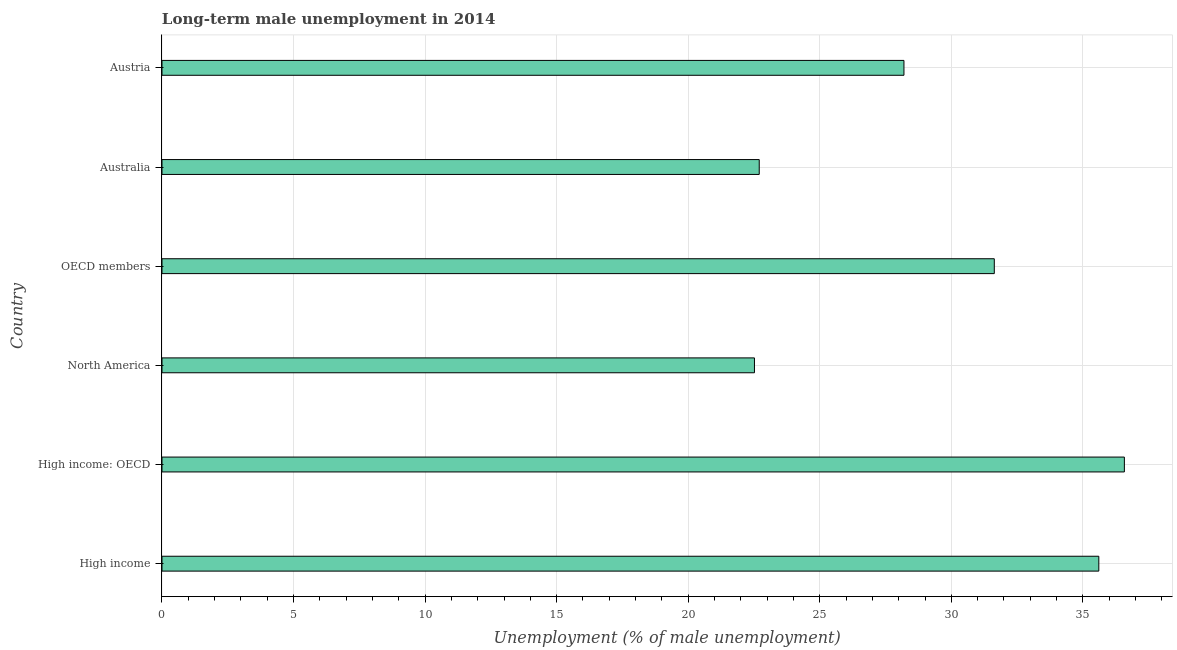Does the graph contain any zero values?
Your answer should be very brief. No. Does the graph contain grids?
Ensure brevity in your answer.  Yes. What is the title of the graph?
Make the answer very short. Long-term male unemployment in 2014. What is the label or title of the X-axis?
Keep it short and to the point. Unemployment (% of male unemployment). What is the label or title of the Y-axis?
Offer a very short reply. Country. What is the long-term male unemployment in OECD members?
Make the answer very short. 31.63. Across all countries, what is the maximum long-term male unemployment?
Your response must be concise. 36.58. Across all countries, what is the minimum long-term male unemployment?
Provide a succinct answer. 22.52. In which country was the long-term male unemployment maximum?
Ensure brevity in your answer.  High income: OECD. What is the sum of the long-term male unemployment?
Provide a short and direct response. 177.24. What is the difference between the long-term male unemployment in Austria and High income?
Provide a succinct answer. -7.41. What is the average long-term male unemployment per country?
Offer a very short reply. 29.54. What is the median long-term male unemployment?
Your response must be concise. 29.92. What is the ratio of the long-term male unemployment in Australia to that in Austria?
Ensure brevity in your answer.  0.81. Is the long-term male unemployment in Austria less than that in High income: OECD?
Provide a short and direct response. Yes. What is the difference between the highest and the second highest long-term male unemployment?
Give a very brief answer. 0.97. What is the difference between the highest and the lowest long-term male unemployment?
Offer a very short reply. 14.06. In how many countries, is the long-term male unemployment greater than the average long-term male unemployment taken over all countries?
Make the answer very short. 3. How many countries are there in the graph?
Give a very brief answer. 6. What is the difference between two consecutive major ticks on the X-axis?
Provide a succinct answer. 5. Are the values on the major ticks of X-axis written in scientific E-notation?
Make the answer very short. No. What is the Unemployment (% of male unemployment) in High income?
Your answer should be very brief. 35.61. What is the Unemployment (% of male unemployment) in High income: OECD?
Ensure brevity in your answer.  36.58. What is the Unemployment (% of male unemployment) in North America?
Your answer should be compact. 22.52. What is the Unemployment (% of male unemployment) of OECD members?
Make the answer very short. 31.63. What is the Unemployment (% of male unemployment) of Australia?
Offer a terse response. 22.7. What is the Unemployment (% of male unemployment) in Austria?
Provide a succinct answer. 28.2. What is the difference between the Unemployment (% of male unemployment) in High income and High income: OECD?
Offer a terse response. -0.97. What is the difference between the Unemployment (% of male unemployment) in High income and North America?
Make the answer very short. 13.09. What is the difference between the Unemployment (% of male unemployment) in High income and OECD members?
Your answer should be very brief. 3.97. What is the difference between the Unemployment (% of male unemployment) in High income and Australia?
Provide a short and direct response. 12.91. What is the difference between the Unemployment (% of male unemployment) in High income and Austria?
Make the answer very short. 7.41. What is the difference between the Unemployment (% of male unemployment) in High income: OECD and North America?
Give a very brief answer. 14.06. What is the difference between the Unemployment (% of male unemployment) in High income: OECD and OECD members?
Provide a short and direct response. 4.94. What is the difference between the Unemployment (% of male unemployment) in High income: OECD and Australia?
Ensure brevity in your answer.  13.88. What is the difference between the Unemployment (% of male unemployment) in High income: OECD and Austria?
Make the answer very short. 8.38. What is the difference between the Unemployment (% of male unemployment) in North America and OECD members?
Ensure brevity in your answer.  -9.12. What is the difference between the Unemployment (% of male unemployment) in North America and Australia?
Provide a short and direct response. -0.18. What is the difference between the Unemployment (% of male unemployment) in North America and Austria?
Keep it short and to the point. -5.68. What is the difference between the Unemployment (% of male unemployment) in OECD members and Australia?
Offer a terse response. 8.93. What is the difference between the Unemployment (% of male unemployment) in OECD members and Austria?
Your answer should be very brief. 3.43. What is the ratio of the Unemployment (% of male unemployment) in High income to that in North America?
Give a very brief answer. 1.58. What is the ratio of the Unemployment (% of male unemployment) in High income to that in OECD members?
Give a very brief answer. 1.13. What is the ratio of the Unemployment (% of male unemployment) in High income to that in Australia?
Offer a terse response. 1.57. What is the ratio of the Unemployment (% of male unemployment) in High income to that in Austria?
Your answer should be very brief. 1.26. What is the ratio of the Unemployment (% of male unemployment) in High income: OECD to that in North America?
Offer a very short reply. 1.62. What is the ratio of the Unemployment (% of male unemployment) in High income: OECD to that in OECD members?
Offer a terse response. 1.16. What is the ratio of the Unemployment (% of male unemployment) in High income: OECD to that in Australia?
Make the answer very short. 1.61. What is the ratio of the Unemployment (% of male unemployment) in High income: OECD to that in Austria?
Provide a succinct answer. 1.3. What is the ratio of the Unemployment (% of male unemployment) in North America to that in OECD members?
Your answer should be very brief. 0.71. What is the ratio of the Unemployment (% of male unemployment) in North America to that in Australia?
Your response must be concise. 0.99. What is the ratio of the Unemployment (% of male unemployment) in North America to that in Austria?
Offer a terse response. 0.8. What is the ratio of the Unemployment (% of male unemployment) in OECD members to that in Australia?
Offer a very short reply. 1.39. What is the ratio of the Unemployment (% of male unemployment) in OECD members to that in Austria?
Your answer should be compact. 1.12. What is the ratio of the Unemployment (% of male unemployment) in Australia to that in Austria?
Your answer should be compact. 0.81. 